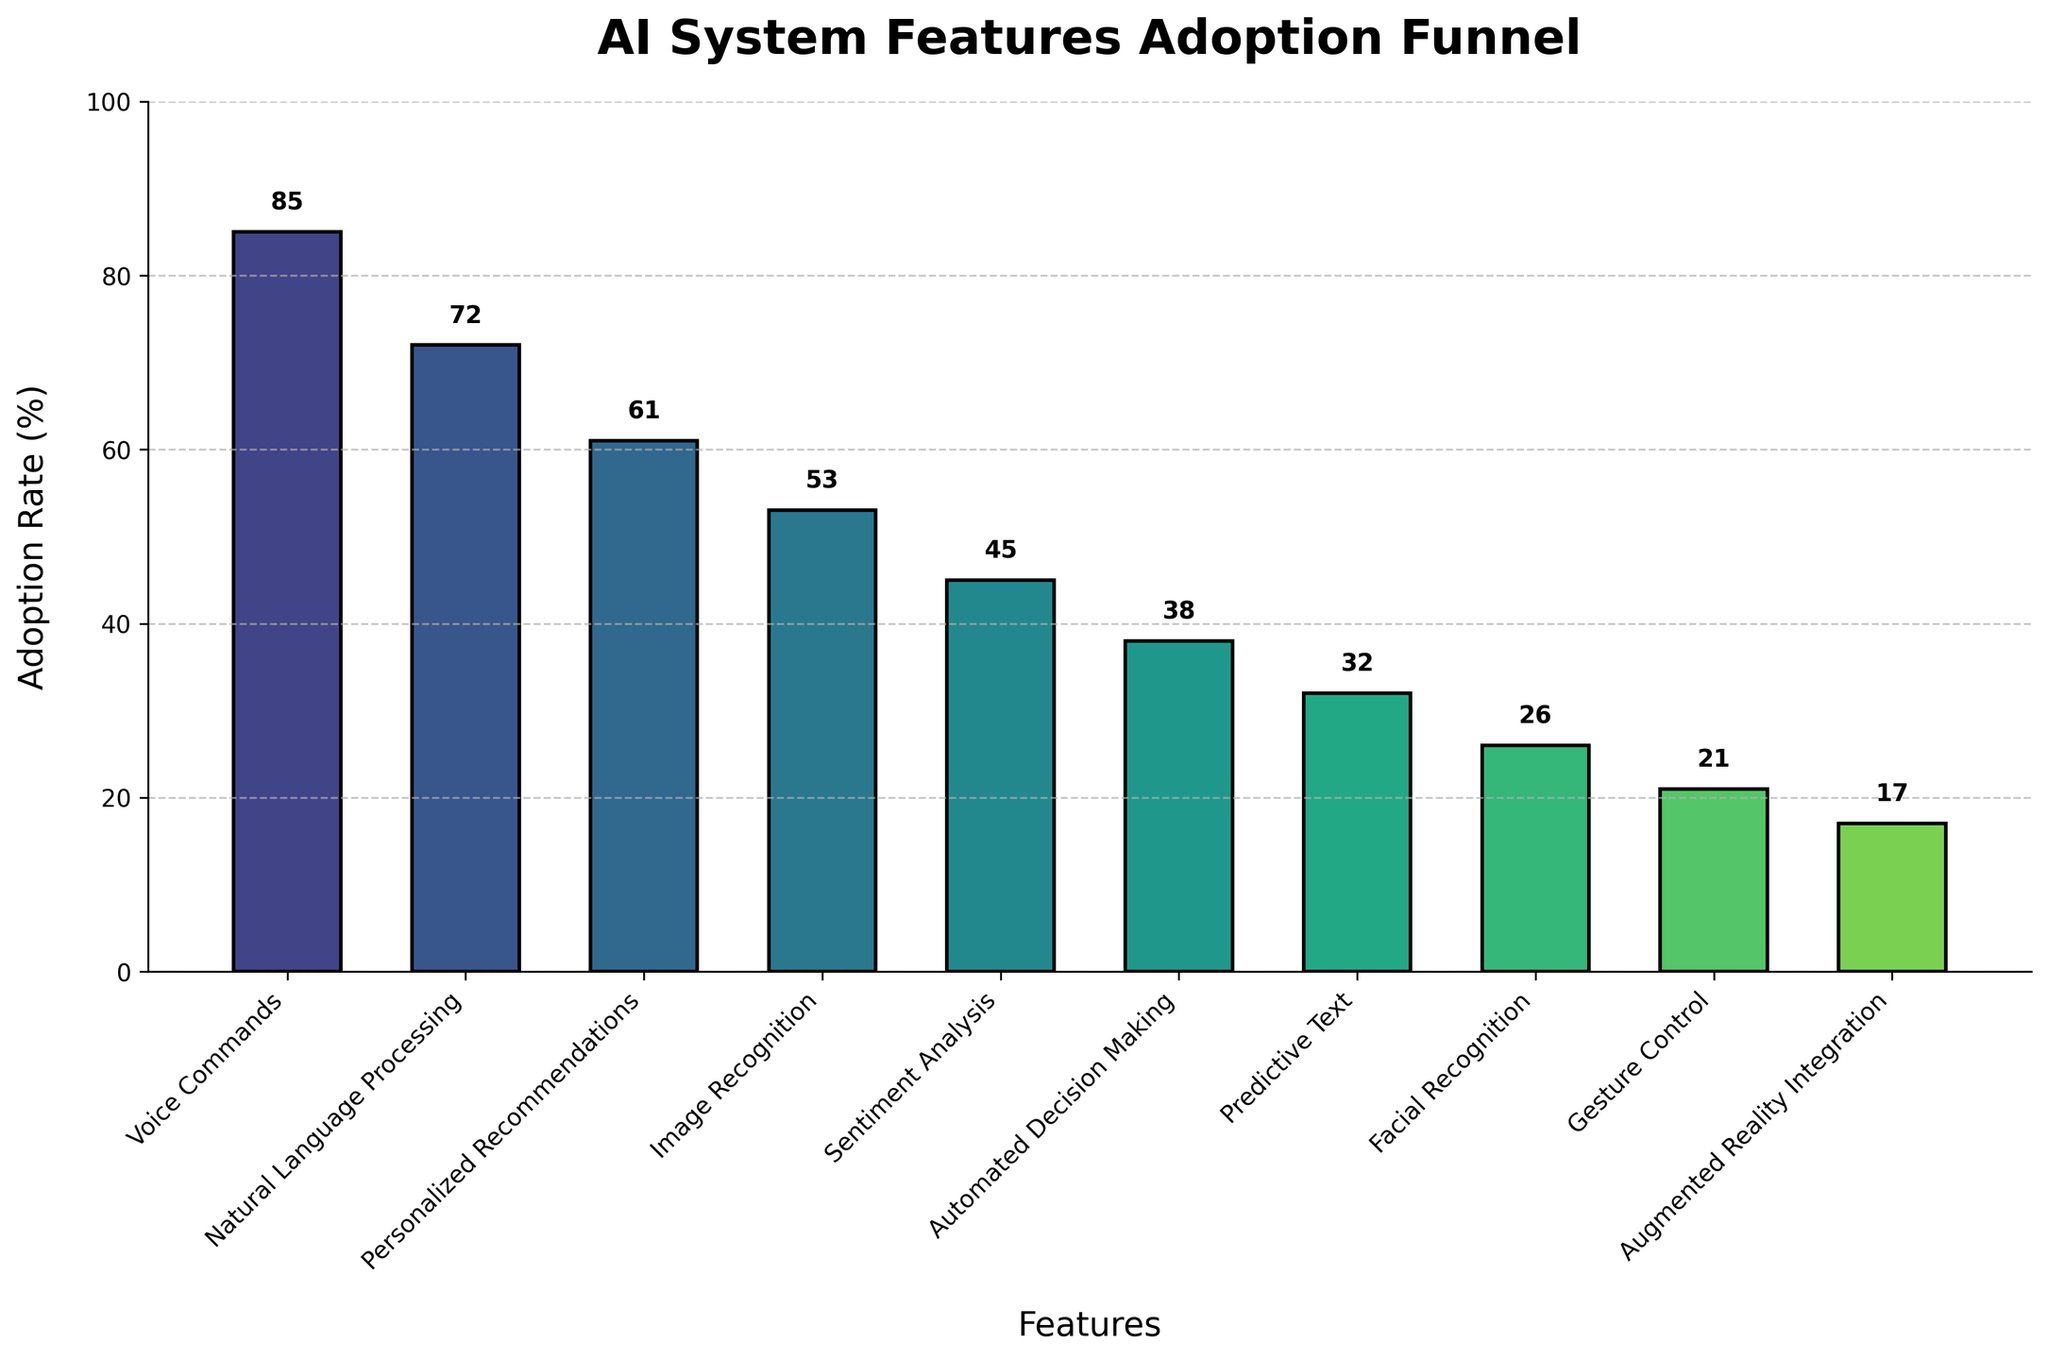What's the title of the figure? The title is usually found at the top of the figure. In this instance, it is "AI System Features Adoption Funnel", which provides context for the subsequent visual data.
Answer: AI System Features Adoption Funnel How many features are displayed in the chart? To find the total number of features, count the individual bars in the funnel chart. Each bar represents one feature. There are 10 features: Voice Commands, Natural Language Processing, Personalized Recommendations, Image Recognition, Sentiment Analysis, Automated Decision Making, Predictive Text, Facial Recognition, Gesture Control, and Augmented Reality Integration.
Answer: 10 Which feature has the highest adoption rate, and what is it? The highest adoption rate feature is at the top of the funnel chart. For this chart, "Voice Commands" is at the top and has an adoption rate of 85%.
Answer: Voice Commands, 85% What is the difference in adoption rates between the highest and lowest adopted features? The highest and lowest adopted features are "Voice Commands" (85%) and "Augmented Reality Integration" (17%), respectively. Subtract 17 from 85 to find the difference: 85 - 17 = 68.
Answer: 68 How many features have an adoption rate above 50%? Identify which bars have adoption rates above the 50% mark using the y-axis. The features that meet this criterion are Voice Commands, Natural Language Processing, Personalized Recommendations, and Image Recognition. Hence, there are 4 features.
Answer: 4 What is the average adoption rate of all the features? Sum all the adoption rates and divide by the number of features: (85 + 72 + 61 + 53 + 45 + 38 + 32 + 26 + 21 + 17) / 10 = 450 / 10 = 45.
Answer: 45 Among "Predictive Text" and "Facial Recognition", which feature has the higher adoption rate and what are their respective rates? Locate both features on the chart. "Predictive Text" has an adoption rate of 32%, and "Facial Recognition" has an adoption rate of 26%. Predictive Text has a higher adoption rate.
Answer: Predictive Text, 32% and Facial Recognition, 26% What is the median adoption rate? To find the median, list all rates in ascending order and find the middle value. For an even number of values, it’s the average of the two central numbers: (17, 21, 26, 32, 38, 45, 53, 61, 72, 85). The median is (38 + 45) / 2 = 83 / 2 = 41.5.
Answer: 41.5 What feature is located directly below Personalized Recommendations and what is its adoption rate? According to the data, the feature directly below Personalized Recommendations (which has 61%) is Image Recognition. Image Recognition has an adoption rate of 53%.
Answer: Image Recognition, 53% 